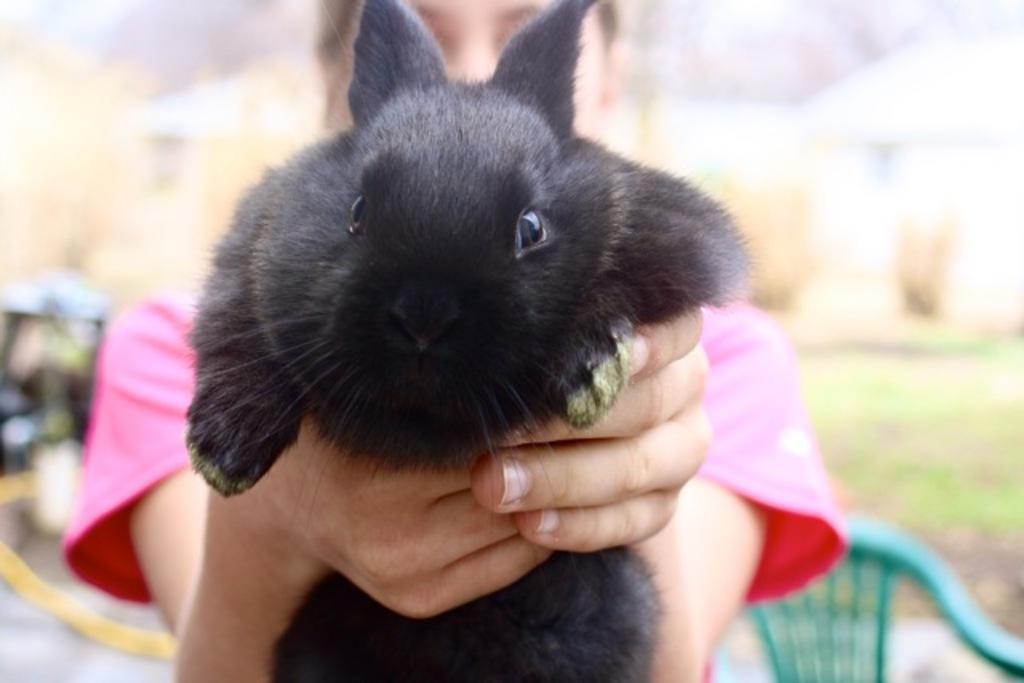In one or two sentences, can you explain what this image depicts? In this image, we can see a person holding a black rabbit. In the background, there is a blur view. In the bottom right side of the image, there is a chair. 